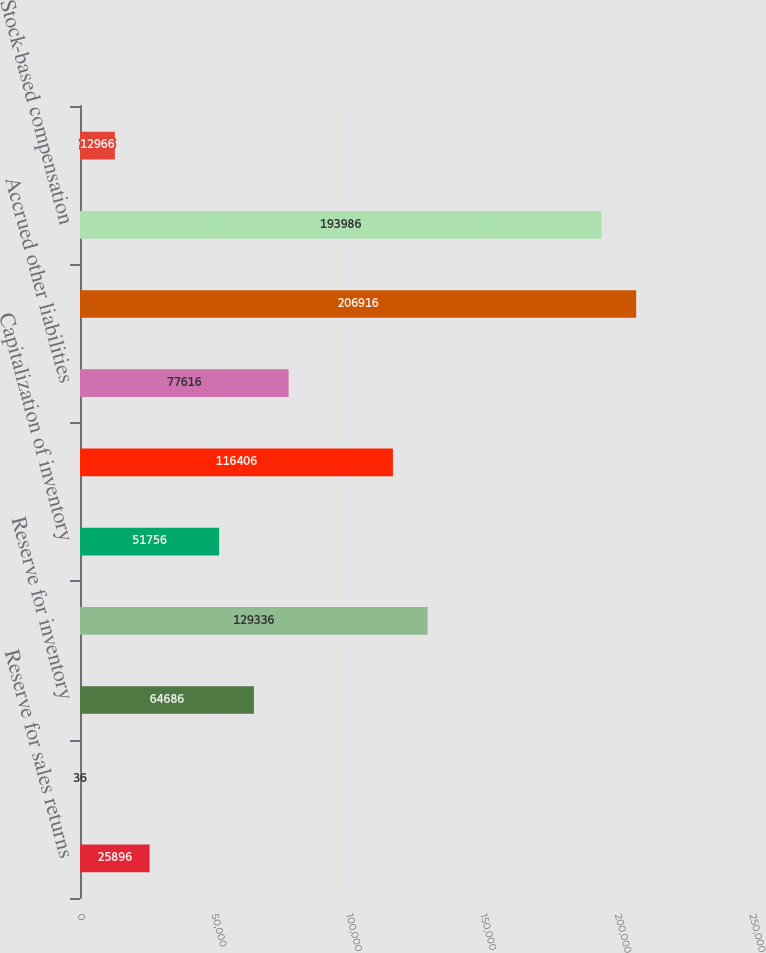Convert chart to OTSL. <chart><loc_0><loc_0><loc_500><loc_500><bar_chart><fcel>Reserve for sales returns<fcel>Reserve for doubtful accounts<fcel>Reserve for inventory<fcel>Reserve for marketing<fcel>Capitalization of inventory<fcel>State franchise tax<fcel>Accrued other liabilities<fcel>Deferred revenue<fcel>Stock-based compensation<fcel>Securities impairment<nl><fcel>25896<fcel>36<fcel>64686<fcel>129336<fcel>51756<fcel>116406<fcel>77616<fcel>206916<fcel>193986<fcel>12966<nl></chart> 